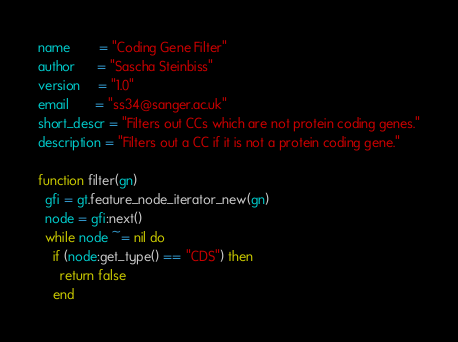<code> <loc_0><loc_0><loc_500><loc_500><_Lua_>name        = "Coding Gene Filter"
author      = "Sascha Steinbiss"
version     = "1.0"
email       = "ss34@sanger.ac.uk"
short_descr = "Filters out CCs which are not protein coding genes."
description = "Filters out a CC if it is not a protein coding gene."

function filter(gn)
  gfi = gt.feature_node_iterator_new(gn)
  node = gfi:next()
  while node ~= nil do
    if (node:get_type() == "CDS") then
      return false
    end</code> 